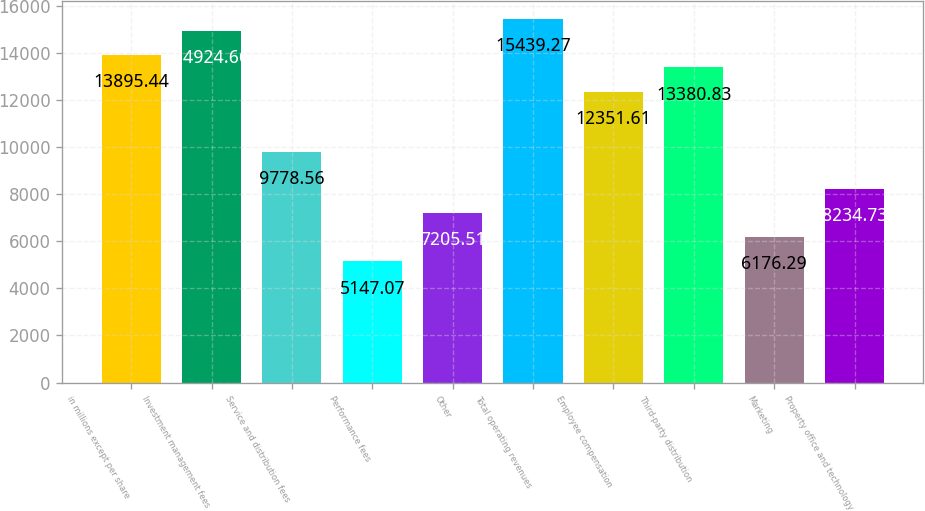<chart> <loc_0><loc_0><loc_500><loc_500><bar_chart><fcel>in millions except per share<fcel>Investment management fees<fcel>Service and distribution fees<fcel>Performance fees<fcel>Other<fcel>Total operating revenues<fcel>Employee compensation<fcel>Third-party distribution<fcel>Marketing<fcel>Property office and technology<nl><fcel>13895.4<fcel>14924.7<fcel>9778.56<fcel>5147.07<fcel>7205.51<fcel>15439.3<fcel>12351.6<fcel>13380.8<fcel>6176.29<fcel>8234.73<nl></chart> 